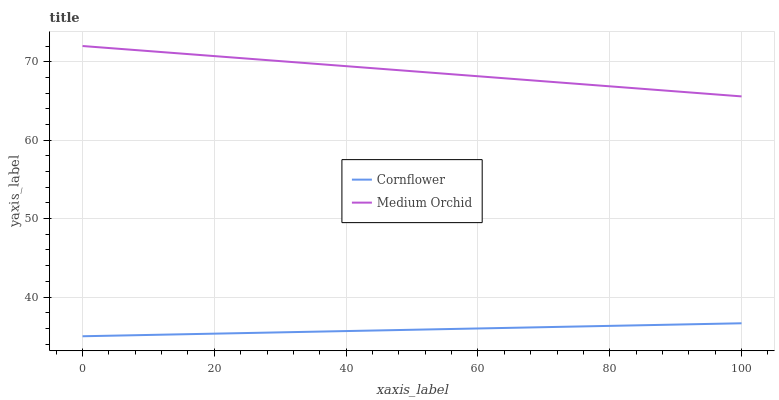Does Cornflower have the minimum area under the curve?
Answer yes or no. Yes. Does Medium Orchid have the maximum area under the curve?
Answer yes or no. Yes. Does Medium Orchid have the minimum area under the curve?
Answer yes or no. No. Is Cornflower the smoothest?
Answer yes or no. Yes. Is Medium Orchid the roughest?
Answer yes or no. Yes. Is Medium Orchid the smoothest?
Answer yes or no. No. Does Medium Orchid have the lowest value?
Answer yes or no. No. Does Medium Orchid have the highest value?
Answer yes or no. Yes. Is Cornflower less than Medium Orchid?
Answer yes or no. Yes. Is Medium Orchid greater than Cornflower?
Answer yes or no. Yes. Does Cornflower intersect Medium Orchid?
Answer yes or no. No. 